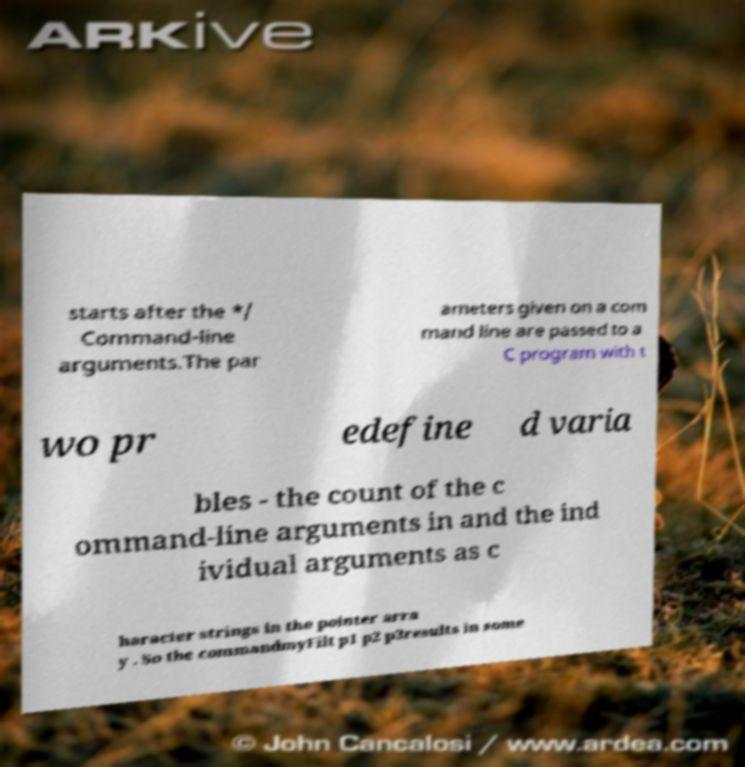For documentation purposes, I need the text within this image transcribed. Could you provide that? starts after the */ Command-line arguments.The par ameters given on a com mand line are passed to a C program with t wo pr edefine d varia bles - the count of the c ommand-line arguments in and the ind ividual arguments as c haracter strings in the pointer arra y . So the commandmyFilt p1 p2 p3results in some 